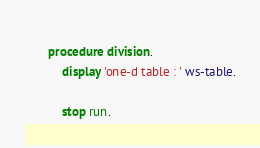Convert code to text. <code><loc_0><loc_0><loc_500><loc_500><_COBOL_>           
       procedure division.
           display 'one-d table : ' ws-table.

           stop run.
</code> 